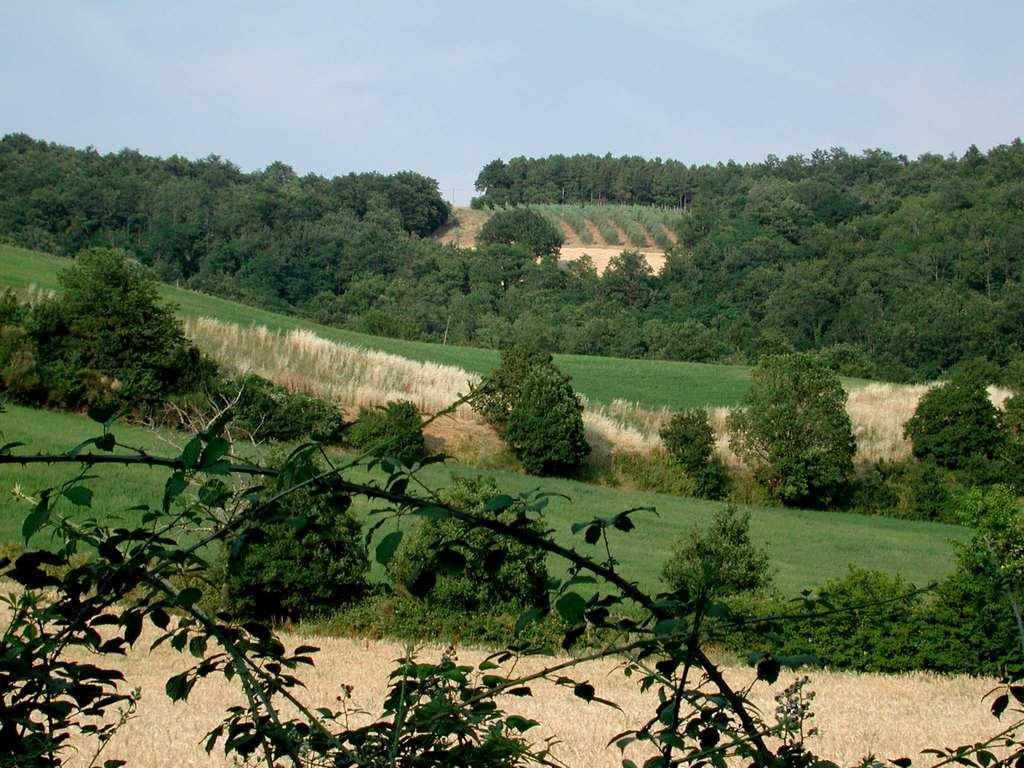How would you summarize this image in a sentence or two? In this image we can see many trees. Image also consists of the grass. At the top there is sky. 